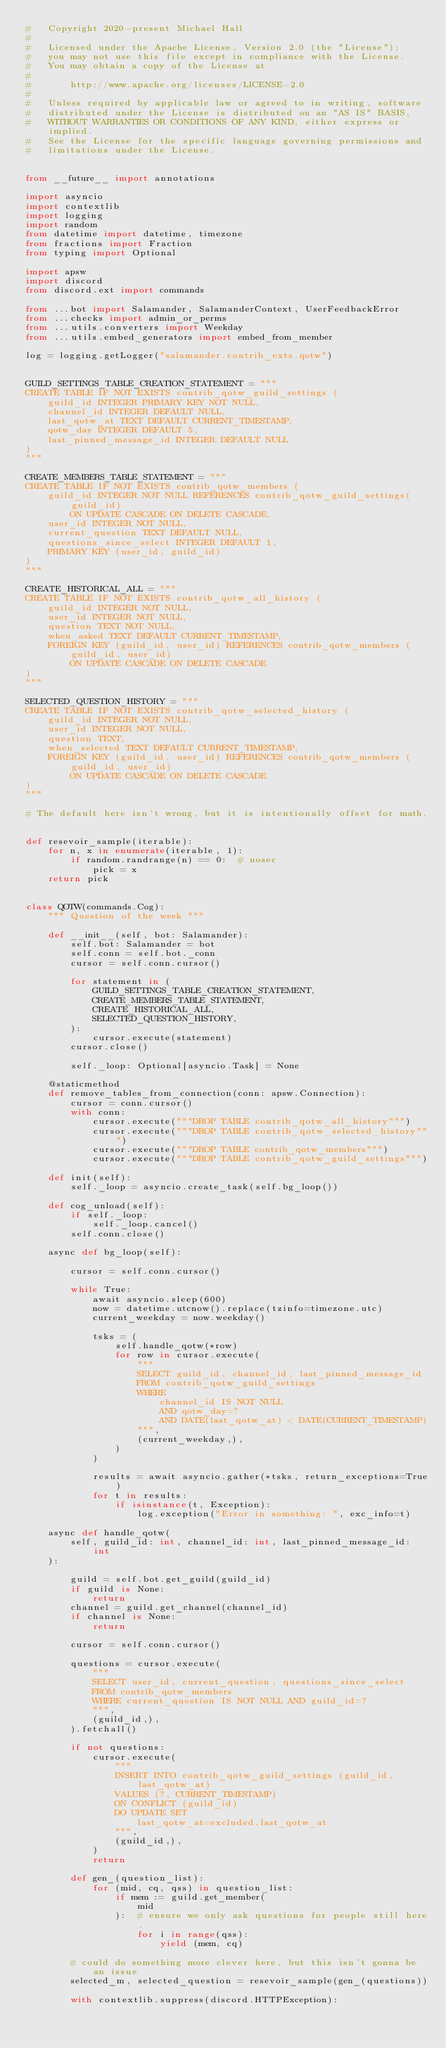<code> <loc_0><loc_0><loc_500><loc_500><_Python_>#   Copyright 2020-present Michael Hall
#
#   Licensed under the Apache License, Version 2.0 (the "License");
#   you may not use this file except in compliance with the License.
#   You may obtain a copy of the License at
#
#       http://www.apache.org/licenses/LICENSE-2.0
#
#   Unless required by applicable law or agreed to in writing, software
#   distributed under the License is distributed on an "AS IS" BASIS,
#   WITHOUT WARRANTIES OR CONDITIONS OF ANY KIND, either express or implied.
#   See the License for the specific language governing permissions and
#   limitations under the License.


from __future__ import annotations

import asyncio
import contextlib
import logging
import random
from datetime import datetime, timezone
from fractions import Fraction
from typing import Optional

import apsw
import discord
from discord.ext import commands

from ...bot import Salamander, SalamanderContext, UserFeedbackError
from ...checks import admin_or_perms
from ...utils.converters import Weekday
from ...utils.embed_generators import embed_from_member

log = logging.getLogger("salamander.contrib_exts.qotw")


GUILD_SETTINGS_TABLE_CREATION_STATEMENT = """
CREATE TABLE IF NOT EXISTS contrib_qotw_guild_settings (
    guild_id INTEGER PRIMARY KEY NOT NULL,
    channel_id INTEGER DEFAULT NULL,
    last_qotw_at TEXT DEFAULT CURRENT_TIMESTAMP,
    qotw_day INTEGER DEFAULT 5,
    last_pinned_message_id INTEGER DEFAULT NULL
)
"""

CREATE_MEMBERS_TABLE_STATEMENT = """
CREATE TABLE IF NOT EXISTS contrib_qotw_members (
    guild_id INTEGER NOT NULL REFERENCES contrib_qotw_guild_settings(guild_id)
        ON UPDATE CASCADE ON DELETE CASCADE,
    user_id INTEGER NOT NULL,
    current_question TEXT DEFAULT NULL,
    questions_since_select INTEGER DEFAULT 1,
    PRIMARY KEY (user_id, guild_id)
)
"""

CREATE_HISTORICAL_ALL = """
CREATE TABLE IF NOT EXISTS contrib_qotw_all_history (
    guild_id INTEGER NOT NULL,
    user_id INTEGER NOT NULL,
    question TEXT NOT NULL,
    when_asked TEXT DEFAULT CURRENT_TIMESTAMP,
    FOREIGN KEY (guild_id, user_id) REFERENCES contrib_qotw_members (guild_id, user_id)
        ON UPDATE CASCADE ON DELETE CASCADE
)
"""

SELECTED_QUESTION_HISTORY = """
CREATE TABLE IF NOT EXISTS contrib_qotw_selected_history (
    guild_id INTEGER NOT NULL,
    user_id INTEGER NOT NULL,
    question TEXT,
    when_selected TEXT DEFAULT CURRENT_TIMESTAMP,
    FOREIGN KEY (guild_id, user_id) REFERENCES contrib_qotw_members (guild_id, user_id)
        ON UPDATE CASCADE ON DELETE CASCADE
)
"""

# The default here isn't wrong, but it is intentionally offset for math.


def resevoir_sample(iterable):
    for n, x in enumerate(iterable, 1):
        if random.randrange(n) == 0:  # nosec
            pick = x
    return pick


class QOTW(commands.Cog):
    """ Question of the week """

    def __init__(self, bot: Salamander):
        self.bot: Salamander = bot
        self.conn = self.bot._conn
        cursor = self.conn.cursor()

        for statement in (
            GUILD_SETTINGS_TABLE_CREATION_STATEMENT,
            CREATE_MEMBERS_TABLE_STATEMENT,
            CREATE_HISTORICAL_ALL,
            SELECTED_QUESTION_HISTORY,
        ):
            cursor.execute(statement)
        cursor.close()

        self._loop: Optional[asyncio.Task] = None

    @staticmethod
    def remove_tables_from_connection(conn: apsw.Connection):
        cursor = conn.cursor()
        with conn:
            cursor.execute("""DROP TABLE contrib_qotw_all_history""")
            cursor.execute("""DROP TABLE contrib_qotw_selected_history""")
            cursor.execute("""DROP TABLE contrib_qotw_members""")
            cursor.execute("""DROP TABLE contrib_qotw_guild_settings""")

    def init(self):
        self._loop = asyncio.create_task(self.bg_loop())

    def cog_unload(self):
        if self._loop:
            self._loop.cancel()
        self.conn.close()

    async def bg_loop(self):

        cursor = self.conn.cursor()

        while True:
            await asyncio.sleep(600)
            now = datetime.utcnow().replace(tzinfo=timezone.utc)
            current_weekday = now.weekday()

            tsks = (
                self.handle_qotw(*row)
                for row in cursor.execute(
                    """
                    SELECT guild_id, channel_id, last_pinned_message_id
                    FROM contrib_qotw_guild_settings
                    WHERE
                        channel_id IS NOT NULL
                        AND qotw_day=?
                        AND DATE(last_qotw_at) < DATE(CURRENT_TIMESTAMP)
                    """,
                    (current_weekday,),
                )
            )

            results = await asyncio.gather(*tsks, return_exceptions=True)
            for t in results:
                if isinstance(t, Exception):
                    log.exception("Error in something: ", exc_info=t)

    async def handle_qotw(
        self, guild_id: int, channel_id: int, last_pinned_message_id: int
    ):

        guild = self.bot.get_guild(guild_id)
        if guild is None:
            return
        channel = guild.get_channel(channel_id)
        if channel is None:
            return

        cursor = self.conn.cursor()

        questions = cursor.execute(
            """
            SELECT user_id, current_question, questions_since_select
            FROM contrib_qotw_members
            WHERE current_question IS NOT NULL AND guild_id=?
            """,
            (guild_id,),
        ).fetchall()

        if not questions:
            cursor.execute(
                """
                INSERT INTO contrib_qotw_guild_settings (guild_id, last_qotw_at)
                VALUES (?, CURRENT_TIMESTAMP)
                ON CONFLICT (guild_id)
                DO UPDATE SET
                    last_qotw_at=excluded.last_qotw_at
                """,
                (guild_id,),
            )
            return

        def gen_(question_list):
            for (mid, cq, qss) in question_list:
                if mem := guild.get_member(
                    mid
                ):  # ensure we only ask questions for people still here.
                    for i in range(qss):
                        yield (mem, cq)

        # could do something more clever here, but this isn't gonna be an issue
        selected_m, selected_question = resevoir_sample(gen_(questions))

        with contextlib.suppress(discord.HTTPException):</code> 